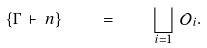Convert formula to latex. <formula><loc_0><loc_0><loc_500><loc_500>\left \{ \Gamma \, \vdash \, n \right \} \quad = \quad \bigsqcup _ { i = 1 } \, \mathcal { O } _ { i } .</formula> 